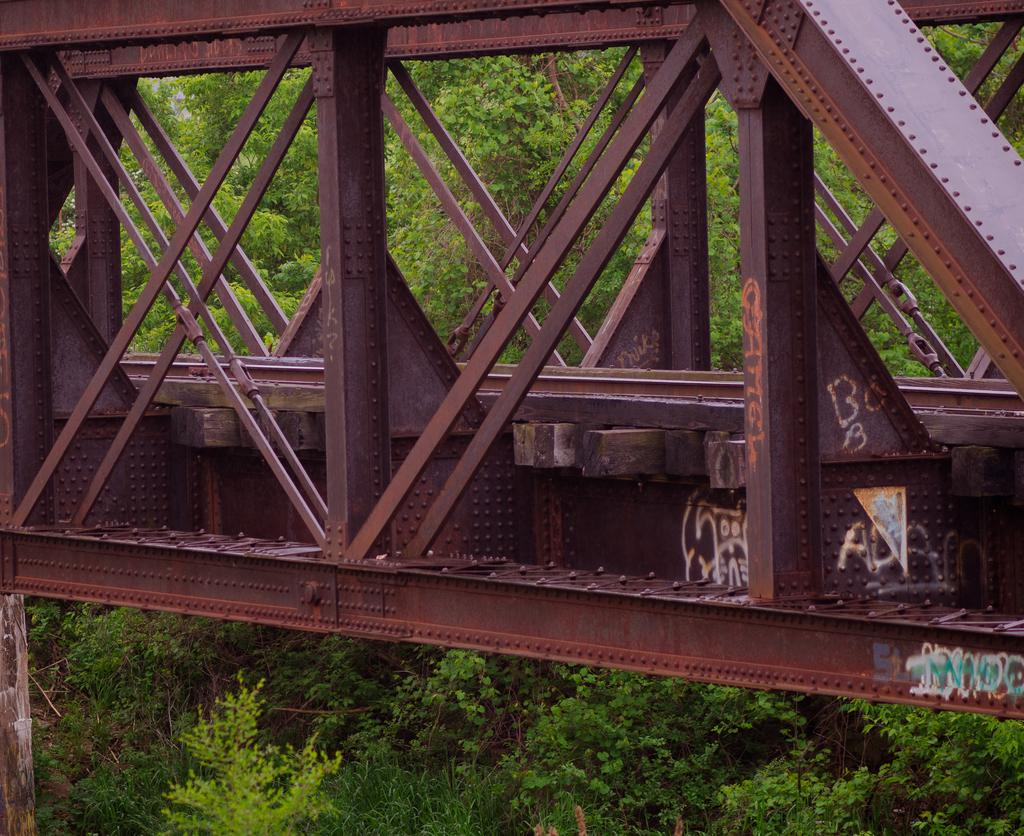What structure is located on the right side of the image? There is a bridge in the image, and it is on the right side. What else can be seen in the image besides the bridge? There are poles in the image. What is written on the bridge? Texts are written on the bridge. What type of vegetation is visible in the background of the image? There are trees and plants on the ground in the background of the image. Can you see a river flowing under the bridge in the image? There is no river visible in the image; it only shows a bridge, poles, texts on the bridge, and the background vegetation. Is there a rabbit hopping on the bridge in the image? There is no rabbit present in the image. 